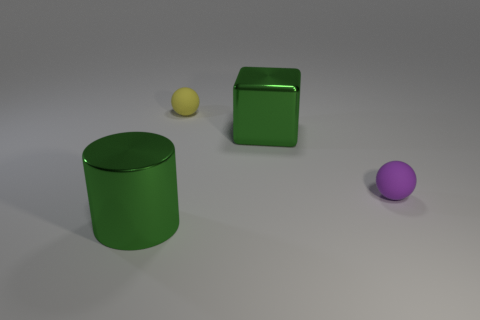What number of green spheres are the same size as the purple sphere?
Give a very brief answer. 0. What is the shape of the big metallic thing that is the same color as the big metal block?
Ensure brevity in your answer.  Cylinder. What is the material of the purple object?
Provide a short and direct response. Rubber. There is a object that is to the right of the green shiny cube; what size is it?
Offer a terse response. Small. How many other tiny purple objects have the same shape as the small purple object?
Your response must be concise. 0. There is a tiny yellow object that is the same material as the purple thing; what is its shape?
Provide a short and direct response. Sphere. How many gray things are either metallic objects or small spheres?
Make the answer very short. 0. Are there any green shiny things left of the small yellow matte thing?
Provide a short and direct response. Yes. Is the shape of the purple matte thing that is behind the metallic cylinder the same as the rubber object that is to the left of the purple matte thing?
Give a very brief answer. Yes. What is the material of the tiny yellow object that is the same shape as the small purple rubber object?
Your answer should be very brief. Rubber. 